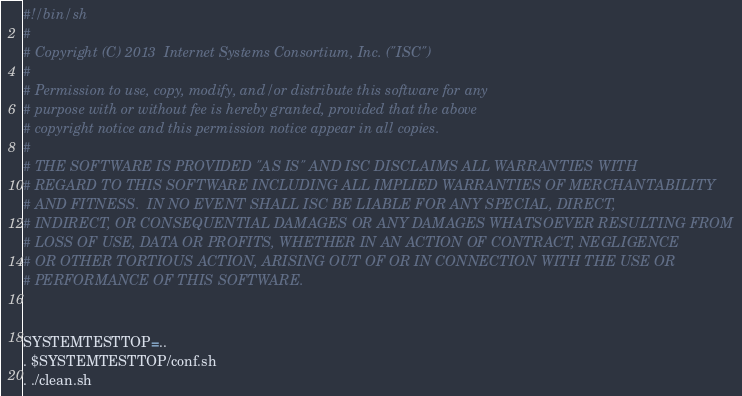Convert code to text. <code><loc_0><loc_0><loc_500><loc_500><_Bash_>#!/bin/sh
#
# Copyright (C) 2013  Internet Systems Consortium, Inc. ("ISC")
#
# Permission to use, copy, modify, and/or distribute this software for any
# purpose with or without fee is hereby granted, provided that the above
# copyright notice and this permission notice appear in all copies.
#
# THE SOFTWARE IS PROVIDED "AS IS" AND ISC DISCLAIMS ALL WARRANTIES WITH
# REGARD TO THIS SOFTWARE INCLUDING ALL IMPLIED WARRANTIES OF MERCHANTABILITY
# AND FITNESS.  IN NO EVENT SHALL ISC BE LIABLE FOR ANY SPECIAL, DIRECT,
# INDIRECT, OR CONSEQUENTIAL DAMAGES OR ANY DAMAGES WHATSOEVER RESULTING FROM
# LOSS OF USE, DATA OR PROFITS, WHETHER IN AN ACTION OF CONTRACT, NEGLIGENCE
# OR OTHER TORTIOUS ACTION, ARISING OUT OF OR IN CONNECTION WITH THE USE OR
# PERFORMANCE OF THIS SOFTWARE.


SYSTEMTESTTOP=..
. $SYSTEMTESTTOP/conf.sh
. ./clean.sh

</code> 